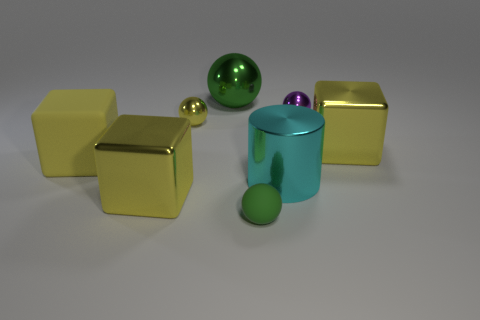Subtract 1 balls. How many balls are left? 3 Add 2 metal balls. How many objects exist? 10 Subtract all cylinders. How many objects are left? 7 Subtract 0 blue blocks. How many objects are left? 8 Subtract all purple spheres. Subtract all large cylinders. How many objects are left? 6 Add 8 cyan cylinders. How many cyan cylinders are left? 9 Add 5 big yellow shiny cubes. How many big yellow shiny cubes exist? 7 